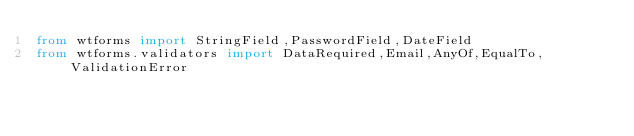Convert code to text. <code><loc_0><loc_0><loc_500><loc_500><_Python_>from wtforms import StringField,PasswordField,DateField
from wtforms.validators import DataRequired,Email,AnyOf,EqualTo,ValidationError</code> 